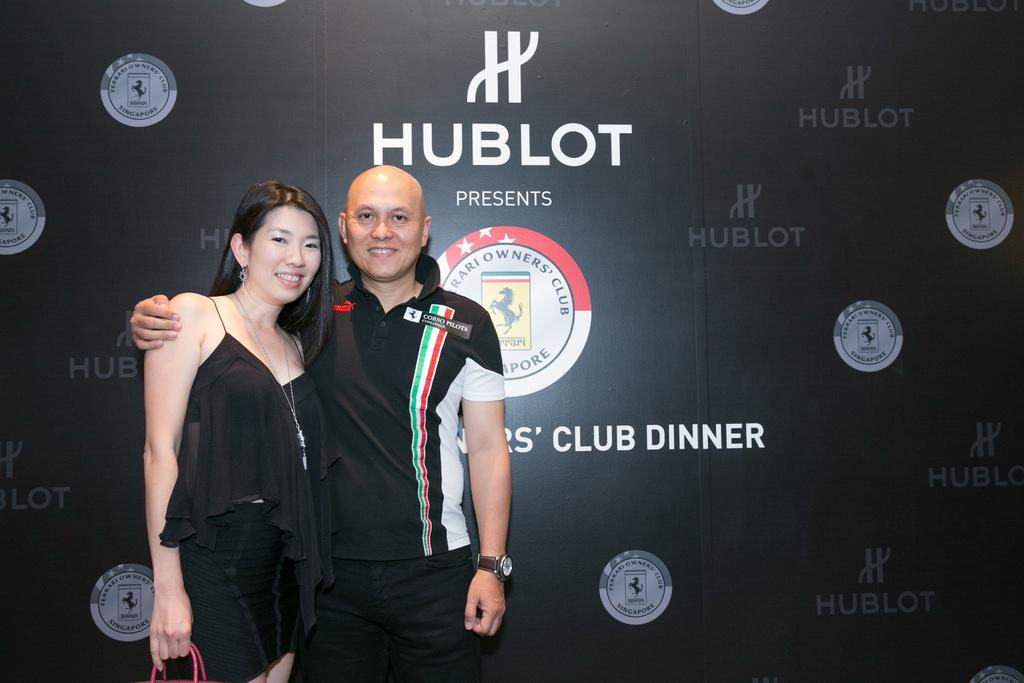Provide a one-sentence caption for the provided image. Two people at the Ferrari Club Dinner presented by Hublot. 